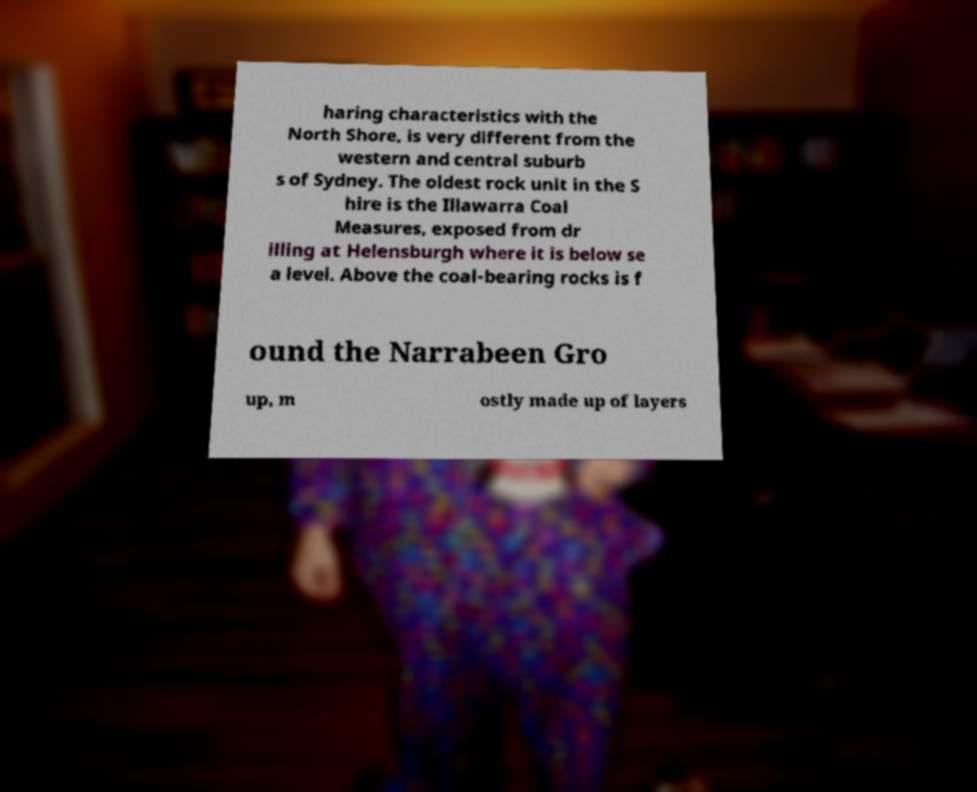Can you accurately transcribe the text from the provided image for me? haring characteristics with the North Shore, is very different from the western and central suburb s of Sydney. The oldest rock unit in the S hire is the Illawarra Coal Measures, exposed from dr illing at Helensburgh where it is below se a level. Above the coal-bearing rocks is f ound the Narrabeen Gro up, m ostly made up of layers 